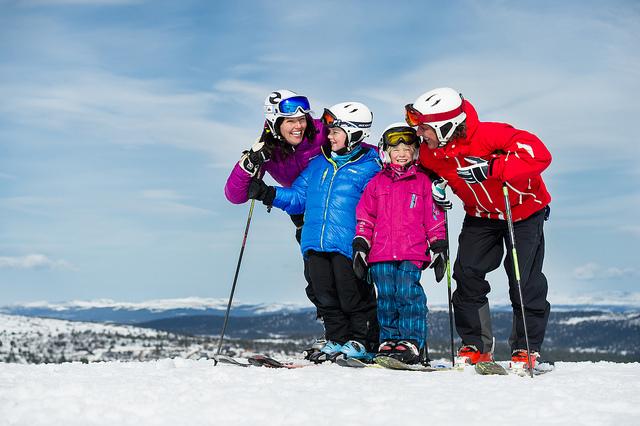Who took this picture?
Be succinct. Photographer. What is behind the kid?
Keep it brief. Sky. Is the man with someone?
Short answer required. Yes. Why is the woman holding the child?
Answer briefly. No. What sport are they going to partake in?
Short answer required. Skiing. Are all the people wearing different colors?
Keep it brief. Yes. What is in the child's hands?
Short answer required. Ski poles. What are the people looking at?
Quick response, please. Camera. How many skiers?
Give a very brief answer. 4. Are the skiers wearing goggles?
Give a very brief answer. Yes. 